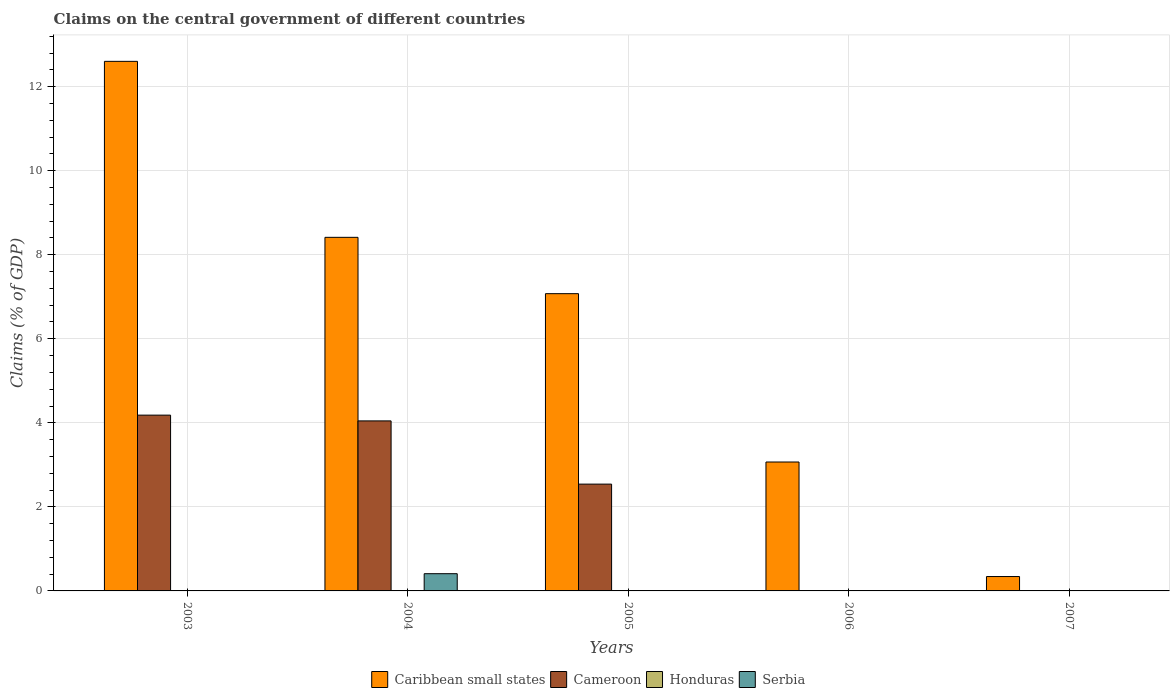How many bars are there on the 1st tick from the left?
Ensure brevity in your answer.  2. What is the label of the 5th group of bars from the left?
Provide a short and direct response. 2007. In how many cases, is the number of bars for a given year not equal to the number of legend labels?
Offer a terse response. 5. Across all years, what is the maximum percentage of GDP claimed on the central government in Serbia?
Your answer should be compact. 0.41. What is the total percentage of GDP claimed on the central government in Serbia in the graph?
Provide a succinct answer. 0.41. What is the difference between the percentage of GDP claimed on the central government in Caribbean small states in 2006 and that in 2007?
Give a very brief answer. 2.73. What is the difference between the percentage of GDP claimed on the central government in Serbia in 2007 and the percentage of GDP claimed on the central government in Caribbean small states in 2005?
Ensure brevity in your answer.  -7.07. What is the average percentage of GDP claimed on the central government in Serbia per year?
Ensure brevity in your answer.  0.08. In the year 2004, what is the difference between the percentage of GDP claimed on the central government in Cameroon and percentage of GDP claimed on the central government in Caribbean small states?
Your answer should be very brief. -4.37. In how many years, is the percentage of GDP claimed on the central government in Cameroon greater than 2.4 %?
Provide a short and direct response. 3. What is the ratio of the percentage of GDP claimed on the central government in Caribbean small states in 2004 to that in 2006?
Keep it short and to the point. 2.74. What is the difference between the highest and the second highest percentage of GDP claimed on the central government in Caribbean small states?
Your response must be concise. 4.19. What is the difference between the highest and the lowest percentage of GDP claimed on the central government in Cameroon?
Your answer should be very brief. 4.18. Is the sum of the percentage of GDP claimed on the central government in Caribbean small states in 2004 and 2006 greater than the maximum percentage of GDP claimed on the central government in Cameroon across all years?
Ensure brevity in your answer.  Yes. Is it the case that in every year, the sum of the percentage of GDP claimed on the central government in Serbia and percentage of GDP claimed on the central government in Cameroon is greater than the sum of percentage of GDP claimed on the central government in Caribbean small states and percentage of GDP claimed on the central government in Honduras?
Make the answer very short. No. Are all the bars in the graph horizontal?
Your response must be concise. No. Does the graph contain grids?
Provide a succinct answer. Yes. Where does the legend appear in the graph?
Ensure brevity in your answer.  Bottom center. How many legend labels are there?
Offer a terse response. 4. What is the title of the graph?
Provide a short and direct response. Claims on the central government of different countries. Does "Chad" appear as one of the legend labels in the graph?
Your response must be concise. No. What is the label or title of the Y-axis?
Your answer should be very brief. Claims (% of GDP). What is the Claims (% of GDP) in Caribbean small states in 2003?
Provide a succinct answer. 12.6. What is the Claims (% of GDP) of Cameroon in 2003?
Your answer should be very brief. 4.18. What is the Claims (% of GDP) in Serbia in 2003?
Your response must be concise. 0. What is the Claims (% of GDP) of Caribbean small states in 2004?
Your answer should be very brief. 8.41. What is the Claims (% of GDP) of Cameroon in 2004?
Ensure brevity in your answer.  4.05. What is the Claims (% of GDP) of Serbia in 2004?
Your response must be concise. 0.41. What is the Claims (% of GDP) of Caribbean small states in 2005?
Offer a very short reply. 7.07. What is the Claims (% of GDP) in Cameroon in 2005?
Ensure brevity in your answer.  2.54. What is the Claims (% of GDP) in Honduras in 2005?
Give a very brief answer. 0. What is the Claims (% of GDP) of Caribbean small states in 2006?
Provide a succinct answer. 3.07. What is the Claims (% of GDP) in Caribbean small states in 2007?
Keep it short and to the point. 0.34. What is the Claims (% of GDP) in Serbia in 2007?
Offer a very short reply. 0. Across all years, what is the maximum Claims (% of GDP) in Caribbean small states?
Your answer should be very brief. 12.6. Across all years, what is the maximum Claims (% of GDP) in Cameroon?
Offer a terse response. 4.18. Across all years, what is the maximum Claims (% of GDP) of Serbia?
Make the answer very short. 0.41. Across all years, what is the minimum Claims (% of GDP) in Caribbean small states?
Your answer should be very brief. 0.34. Across all years, what is the minimum Claims (% of GDP) of Cameroon?
Provide a succinct answer. 0. What is the total Claims (% of GDP) in Caribbean small states in the graph?
Your answer should be very brief. 31.5. What is the total Claims (% of GDP) of Cameroon in the graph?
Provide a succinct answer. 10.77. What is the total Claims (% of GDP) of Honduras in the graph?
Provide a short and direct response. 0. What is the total Claims (% of GDP) in Serbia in the graph?
Provide a succinct answer. 0.41. What is the difference between the Claims (% of GDP) in Caribbean small states in 2003 and that in 2004?
Give a very brief answer. 4.19. What is the difference between the Claims (% of GDP) in Cameroon in 2003 and that in 2004?
Provide a succinct answer. 0.14. What is the difference between the Claims (% of GDP) of Caribbean small states in 2003 and that in 2005?
Your answer should be compact. 5.53. What is the difference between the Claims (% of GDP) in Cameroon in 2003 and that in 2005?
Your response must be concise. 1.64. What is the difference between the Claims (% of GDP) of Caribbean small states in 2003 and that in 2006?
Keep it short and to the point. 9.53. What is the difference between the Claims (% of GDP) in Caribbean small states in 2003 and that in 2007?
Keep it short and to the point. 12.26. What is the difference between the Claims (% of GDP) of Caribbean small states in 2004 and that in 2005?
Ensure brevity in your answer.  1.34. What is the difference between the Claims (% of GDP) of Cameroon in 2004 and that in 2005?
Offer a very short reply. 1.5. What is the difference between the Claims (% of GDP) in Caribbean small states in 2004 and that in 2006?
Give a very brief answer. 5.35. What is the difference between the Claims (% of GDP) of Caribbean small states in 2004 and that in 2007?
Make the answer very short. 8.07. What is the difference between the Claims (% of GDP) in Caribbean small states in 2005 and that in 2006?
Ensure brevity in your answer.  4.01. What is the difference between the Claims (% of GDP) in Caribbean small states in 2005 and that in 2007?
Your answer should be compact. 6.73. What is the difference between the Claims (% of GDP) in Caribbean small states in 2006 and that in 2007?
Provide a succinct answer. 2.73. What is the difference between the Claims (% of GDP) in Caribbean small states in 2003 and the Claims (% of GDP) in Cameroon in 2004?
Keep it short and to the point. 8.56. What is the difference between the Claims (% of GDP) of Caribbean small states in 2003 and the Claims (% of GDP) of Serbia in 2004?
Ensure brevity in your answer.  12.19. What is the difference between the Claims (% of GDP) in Cameroon in 2003 and the Claims (% of GDP) in Serbia in 2004?
Give a very brief answer. 3.77. What is the difference between the Claims (% of GDP) of Caribbean small states in 2003 and the Claims (% of GDP) of Cameroon in 2005?
Your response must be concise. 10.06. What is the difference between the Claims (% of GDP) of Caribbean small states in 2004 and the Claims (% of GDP) of Cameroon in 2005?
Offer a very short reply. 5.87. What is the average Claims (% of GDP) of Caribbean small states per year?
Your response must be concise. 6.3. What is the average Claims (% of GDP) of Cameroon per year?
Ensure brevity in your answer.  2.15. What is the average Claims (% of GDP) of Honduras per year?
Offer a terse response. 0. What is the average Claims (% of GDP) in Serbia per year?
Your answer should be very brief. 0.08. In the year 2003, what is the difference between the Claims (% of GDP) of Caribbean small states and Claims (% of GDP) of Cameroon?
Offer a terse response. 8.42. In the year 2004, what is the difference between the Claims (% of GDP) in Caribbean small states and Claims (% of GDP) in Cameroon?
Your response must be concise. 4.37. In the year 2004, what is the difference between the Claims (% of GDP) of Caribbean small states and Claims (% of GDP) of Serbia?
Make the answer very short. 8. In the year 2004, what is the difference between the Claims (% of GDP) of Cameroon and Claims (% of GDP) of Serbia?
Your answer should be compact. 3.64. In the year 2005, what is the difference between the Claims (% of GDP) of Caribbean small states and Claims (% of GDP) of Cameroon?
Your response must be concise. 4.53. What is the ratio of the Claims (% of GDP) of Caribbean small states in 2003 to that in 2004?
Provide a short and direct response. 1.5. What is the ratio of the Claims (% of GDP) in Cameroon in 2003 to that in 2004?
Your answer should be compact. 1.03. What is the ratio of the Claims (% of GDP) of Caribbean small states in 2003 to that in 2005?
Make the answer very short. 1.78. What is the ratio of the Claims (% of GDP) in Cameroon in 2003 to that in 2005?
Make the answer very short. 1.65. What is the ratio of the Claims (% of GDP) in Caribbean small states in 2003 to that in 2006?
Your answer should be compact. 4.11. What is the ratio of the Claims (% of GDP) in Caribbean small states in 2003 to that in 2007?
Your response must be concise. 36.83. What is the ratio of the Claims (% of GDP) of Caribbean small states in 2004 to that in 2005?
Your response must be concise. 1.19. What is the ratio of the Claims (% of GDP) in Cameroon in 2004 to that in 2005?
Your response must be concise. 1.59. What is the ratio of the Claims (% of GDP) of Caribbean small states in 2004 to that in 2006?
Provide a succinct answer. 2.74. What is the ratio of the Claims (% of GDP) in Caribbean small states in 2004 to that in 2007?
Provide a succinct answer. 24.59. What is the ratio of the Claims (% of GDP) of Caribbean small states in 2005 to that in 2006?
Your response must be concise. 2.31. What is the ratio of the Claims (% of GDP) of Caribbean small states in 2005 to that in 2007?
Provide a succinct answer. 20.67. What is the ratio of the Claims (% of GDP) in Caribbean small states in 2006 to that in 2007?
Your answer should be compact. 8.96. What is the difference between the highest and the second highest Claims (% of GDP) in Caribbean small states?
Make the answer very short. 4.19. What is the difference between the highest and the second highest Claims (% of GDP) of Cameroon?
Keep it short and to the point. 0.14. What is the difference between the highest and the lowest Claims (% of GDP) in Caribbean small states?
Your answer should be very brief. 12.26. What is the difference between the highest and the lowest Claims (% of GDP) of Cameroon?
Offer a very short reply. 4.18. What is the difference between the highest and the lowest Claims (% of GDP) of Serbia?
Provide a succinct answer. 0.41. 